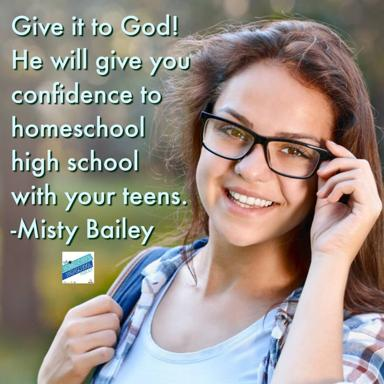How can faith impact the homeschooling experience according to the image? According to the image, faith can play a significant role by providing emotional and spiritual support to parents. It encourages a sense of peace and confidence, making it easier to handle the pressures and responsibilities of educating children at home. 